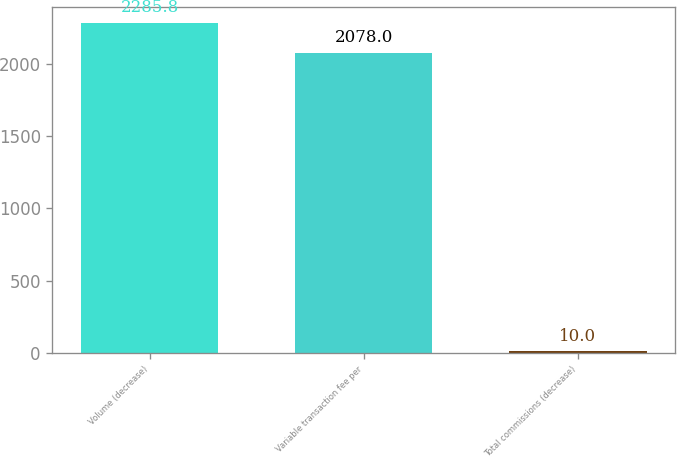<chart> <loc_0><loc_0><loc_500><loc_500><bar_chart><fcel>Volume (decrease)<fcel>Variable transaction fee per<fcel>Total commissions (decrease)<nl><fcel>2285.8<fcel>2078<fcel>10<nl></chart> 